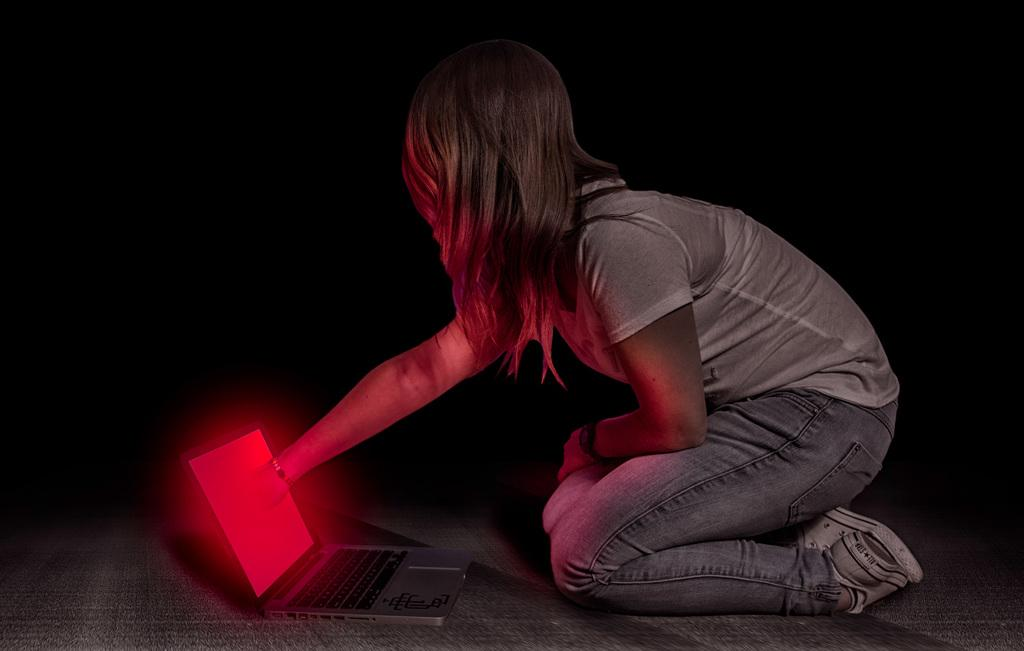Who is the main subject in the image? There is a woman in the image. What is the woman doing in the image? The woman is sitting on the floor. What object is in front of the woman? The woman has a laptop in front of her. What can be observed about the background of the image? The background of the image is dark. Is the woman flying a kite in the image? No, there is no kite present in the image. Is the woman swimming in the image? No, the woman is sitting on the floor, not swimming. 